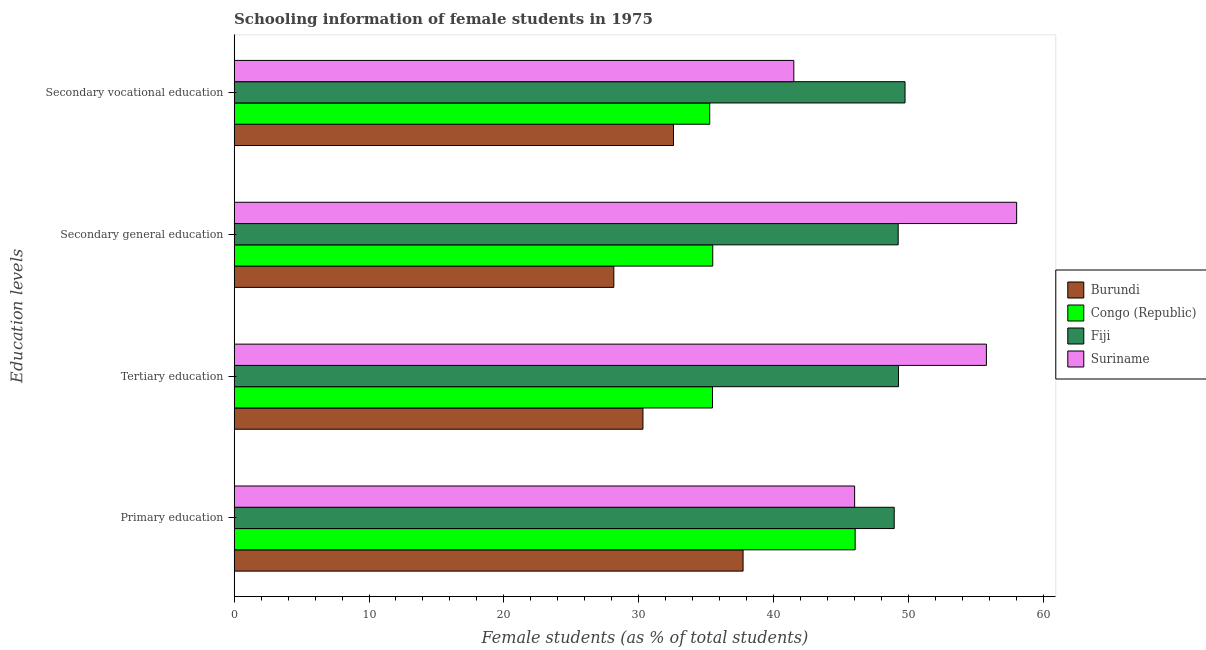How many different coloured bars are there?
Your response must be concise. 4. How many bars are there on the 2nd tick from the top?
Offer a terse response. 4. How many bars are there on the 4th tick from the bottom?
Your response must be concise. 4. What is the label of the 1st group of bars from the top?
Your response must be concise. Secondary vocational education. What is the percentage of female students in primary education in Burundi?
Make the answer very short. 37.73. Across all countries, what is the maximum percentage of female students in primary education?
Offer a very short reply. 48.94. Across all countries, what is the minimum percentage of female students in secondary vocational education?
Your answer should be very brief. 32.57. In which country was the percentage of female students in primary education maximum?
Provide a succinct answer. Fiji. In which country was the percentage of female students in tertiary education minimum?
Ensure brevity in your answer.  Burundi. What is the total percentage of female students in secondary education in the graph?
Provide a succinct answer. 170.87. What is the difference between the percentage of female students in secondary vocational education in Burundi and that in Fiji?
Your response must be concise. -17.16. What is the difference between the percentage of female students in tertiary education in Fiji and the percentage of female students in primary education in Congo (Republic)?
Give a very brief answer. 3.21. What is the average percentage of female students in primary education per country?
Your answer should be very brief. 44.68. What is the difference between the percentage of female students in secondary education and percentage of female students in primary education in Burundi?
Your response must be concise. -9.58. What is the ratio of the percentage of female students in secondary education in Burundi to that in Congo (Republic)?
Ensure brevity in your answer.  0.79. What is the difference between the highest and the second highest percentage of female students in tertiary education?
Your answer should be very brief. 6.52. What is the difference between the highest and the lowest percentage of female students in primary education?
Ensure brevity in your answer.  11.2. What does the 4th bar from the top in Tertiary education represents?
Ensure brevity in your answer.  Burundi. What does the 3rd bar from the bottom in Primary education represents?
Ensure brevity in your answer.  Fiji. Are all the bars in the graph horizontal?
Provide a short and direct response. Yes. How many countries are there in the graph?
Offer a very short reply. 4. Does the graph contain any zero values?
Ensure brevity in your answer.  No. Where does the legend appear in the graph?
Offer a very short reply. Center right. What is the title of the graph?
Give a very brief answer. Schooling information of female students in 1975. What is the label or title of the X-axis?
Offer a very short reply. Female students (as % of total students). What is the label or title of the Y-axis?
Keep it short and to the point. Education levels. What is the Female students (as % of total students) in Burundi in Primary education?
Your answer should be very brief. 37.73. What is the Female students (as % of total students) of Congo (Republic) in Primary education?
Provide a short and direct response. 46.04. What is the Female students (as % of total students) of Fiji in Primary education?
Ensure brevity in your answer.  48.94. What is the Female students (as % of total students) in Suriname in Primary education?
Offer a terse response. 46. What is the Female students (as % of total students) of Burundi in Tertiary education?
Your answer should be compact. 30.31. What is the Female students (as % of total students) of Congo (Republic) in Tertiary education?
Make the answer very short. 35.47. What is the Female students (as % of total students) in Fiji in Tertiary education?
Your response must be concise. 49.25. What is the Female students (as % of total students) in Suriname in Tertiary education?
Ensure brevity in your answer.  55.77. What is the Female students (as % of total students) of Burundi in Secondary general education?
Offer a terse response. 28.15. What is the Female students (as % of total students) of Congo (Republic) in Secondary general education?
Offer a terse response. 35.48. What is the Female students (as % of total students) in Fiji in Secondary general education?
Keep it short and to the point. 49.23. What is the Female students (as % of total students) in Suriname in Secondary general education?
Provide a short and direct response. 58.01. What is the Female students (as % of total students) of Burundi in Secondary vocational education?
Provide a succinct answer. 32.57. What is the Female students (as % of total students) in Congo (Republic) in Secondary vocational education?
Give a very brief answer. 35.26. What is the Female students (as % of total students) in Fiji in Secondary vocational education?
Your answer should be very brief. 49.74. What is the Female students (as % of total students) of Suriname in Secondary vocational education?
Give a very brief answer. 41.49. Across all Education levels, what is the maximum Female students (as % of total students) of Burundi?
Provide a succinct answer. 37.73. Across all Education levels, what is the maximum Female students (as % of total students) in Congo (Republic)?
Provide a short and direct response. 46.04. Across all Education levels, what is the maximum Female students (as % of total students) in Fiji?
Offer a very short reply. 49.74. Across all Education levels, what is the maximum Female students (as % of total students) of Suriname?
Provide a short and direct response. 58.01. Across all Education levels, what is the minimum Female students (as % of total students) in Burundi?
Make the answer very short. 28.15. Across all Education levels, what is the minimum Female students (as % of total students) in Congo (Republic)?
Ensure brevity in your answer.  35.26. Across all Education levels, what is the minimum Female students (as % of total students) in Fiji?
Provide a short and direct response. 48.94. Across all Education levels, what is the minimum Female students (as % of total students) of Suriname?
Offer a very short reply. 41.49. What is the total Female students (as % of total students) in Burundi in the graph?
Provide a short and direct response. 128.76. What is the total Female students (as % of total students) of Congo (Republic) in the graph?
Keep it short and to the point. 152.24. What is the total Female students (as % of total students) of Fiji in the graph?
Keep it short and to the point. 197.15. What is the total Female students (as % of total students) of Suriname in the graph?
Make the answer very short. 201.27. What is the difference between the Female students (as % of total students) of Burundi in Primary education and that in Tertiary education?
Make the answer very short. 7.42. What is the difference between the Female students (as % of total students) of Congo (Republic) in Primary education and that in Tertiary education?
Make the answer very short. 10.57. What is the difference between the Female students (as % of total students) in Fiji in Primary education and that in Tertiary education?
Offer a very short reply. -0.31. What is the difference between the Female students (as % of total students) in Suriname in Primary education and that in Tertiary education?
Make the answer very short. -9.77. What is the difference between the Female students (as % of total students) in Burundi in Primary education and that in Secondary general education?
Provide a short and direct response. 9.58. What is the difference between the Female students (as % of total students) in Congo (Republic) in Primary education and that in Secondary general education?
Provide a short and direct response. 10.56. What is the difference between the Female students (as % of total students) of Fiji in Primary education and that in Secondary general education?
Your answer should be compact. -0.29. What is the difference between the Female students (as % of total students) of Suriname in Primary education and that in Secondary general education?
Ensure brevity in your answer.  -12.01. What is the difference between the Female students (as % of total students) in Burundi in Primary education and that in Secondary vocational education?
Offer a terse response. 5.16. What is the difference between the Female students (as % of total students) of Congo (Republic) in Primary education and that in Secondary vocational education?
Offer a very short reply. 10.78. What is the difference between the Female students (as % of total students) in Fiji in Primary education and that in Secondary vocational education?
Make the answer very short. -0.8. What is the difference between the Female students (as % of total students) of Suriname in Primary education and that in Secondary vocational education?
Your answer should be compact. 4.51. What is the difference between the Female students (as % of total students) of Burundi in Tertiary education and that in Secondary general education?
Your response must be concise. 2.16. What is the difference between the Female students (as % of total students) in Congo (Republic) in Tertiary education and that in Secondary general education?
Provide a short and direct response. -0.02. What is the difference between the Female students (as % of total students) in Fiji in Tertiary education and that in Secondary general education?
Give a very brief answer. 0.02. What is the difference between the Female students (as % of total students) of Suriname in Tertiary education and that in Secondary general education?
Give a very brief answer. -2.24. What is the difference between the Female students (as % of total students) of Burundi in Tertiary education and that in Secondary vocational education?
Make the answer very short. -2.26. What is the difference between the Female students (as % of total students) in Congo (Republic) in Tertiary education and that in Secondary vocational education?
Make the answer very short. 0.21. What is the difference between the Female students (as % of total students) in Fiji in Tertiary education and that in Secondary vocational education?
Provide a succinct answer. -0.49. What is the difference between the Female students (as % of total students) of Suriname in Tertiary education and that in Secondary vocational education?
Provide a succinct answer. 14.28. What is the difference between the Female students (as % of total students) of Burundi in Secondary general education and that in Secondary vocational education?
Your answer should be very brief. -4.42. What is the difference between the Female students (as % of total students) in Congo (Republic) in Secondary general education and that in Secondary vocational education?
Ensure brevity in your answer.  0.22. What is the difference between the Female students (as % of total students) in Fiji in Secondary general education and that in Secondary vocational education?
Make the answer very short. -0.51. What is the difference between the Female students (as % of total students) of Suriname in Secondary general education and that in Secondary vocational education?
Your response must be concise. 16.52. What is the difference between the Female students (as % of total students) of Burundi in Primary education and the Female students (as % of total students) of Congo (Republic) in Tertiary education?
Make the answer very short. 2.27. What is the difference between the Female students (as % of total students) in Burundi in Primary education and the Female students (as % of total students) in Fiji in Tertiary education?
Your response must be concise. -11.52. What is the difference between the Female students (as % of total students) in Burundi in Primary education and the Female students (as % of total students) in Suriname in Tertiary education?
Provide a succinct answer. -18.04. What is the difference between the Female students (as % of total students) of Congo (Republic) in Primary education and the Female students (as % of total students) of Fiji in Tertiary education?
Offer a very short reply. -3.21. What is the difference between the Female students (as % of total students) in Congo (Republic) in Primary education and the Female students (as % of total students) in Suriname in Tertiary education?
Make the answer very short. -9.73. What is the difference between the Female students (as % of total students) in Fiji in Primary education and the Female students (as % of total students) in Suriname in Tertiary education?
Give a very brief answer. -6.83. What is the difference between the Female students (as % of total students) of Burundi in Primary education and the Female students (as % of total students) of Congo (Republic) in Secondary general education?
Your response must be concise. 2.25. What is the difference between the Female students (as % of total students) of Burundi in Primary education and the Female students (as % of total students) of Fiji in Secondary general education?
Your answer should be very brief. -11.5. What is the difference between the Female students (as % of total students) of Burundi in Primary education and the Female students (as % of total students) of Suriname in Secondary general education?
Give a very brief answer. -20.28. What is the difference between the Female students (as % of total students) of Congo (Republic) in Primary education and the Female students (as % of total students) of Fiji in Secondary general education?
Your response must be concise. -3.19. What is the difference between the Female students (as % of total students) of Congo (Republic) in Primary education and the Female students (as % of total students) of Suriname in Secondary general education?
Provide a short and direct response. -11.97. What is the difference between the Female students (as % of total students) in Fiji in Primary education and the Female students (as % of total students) in Suriname in Secondary general education?
Your answer should be very brief. -9.08. What is the difference between the Female students (as % of total students) in Burundi in Primary education and the Female students (as % of total students) in Congo (Republic) in Secondary vocational education?
Keep it short and to the point. 2.47. What is the difference between the Female students (as % of total students) of Burundi in Primary education and the Female students (as % of total students) of Fiji in Secondary vocational education?
Ensure brevity in your answer.  -12.01. What is the difference between the Female students (as % of total students) of Burundi in Primary education and the Female students (as % of total students) of Suriname in Secondary vocational education?
Your response must be concise. -3.76. What is the difference between the Female students (as % of total students) in Congo (Republic) in Primary education and the Female students (as % of total students) in Fiji in Secondary vocational education?
Your response must be concise. -3.7. What is the difference between the Female students (as % of total students) in Congo (Republic) in Primary education and the Female students (as % of total students) in Suriname in Secondary vocational education?
Give a very brief answer. 4.55. What is the difference between the Female students (as % of total students) in Fiji in Primary education and the Female students (as % of total students) in Suriname in Secondary vocational education?
Offer a terse response. 7.44. What is the difference between the Female students (as % of total students) in Burundi in Tertiary education and the Female students (as % of total students) in Congo (Republic) in Secondary general education?
Ensure brevity in your answer.  -5.17. What is the difference between the Female students (as % of total students) of Burundi in Tertiary education and the Female students (as % of total students) of Fiji in Secondary general education?
Your response must be concise. -18.92. What is the difference between the Female students (as % of total students) in Burundi in Tertiary education and the Female students (as % of total students) in Suriname in Secondary general education?
Give a very brief answer. -27.7. What is the difference between the Female students (as % of total students) of Congo (Republic) in Tertiary education and the Female students (as % of total students) of Fiji in Secondary general education?
Offer a very short reply. -13.76. What is the difference between the Female students (as % of total students) in Congo (Republic) in Tertiary education and the Female students (as % of total students) in Suriname in Secondary general education?
Your answer should be compact. -22.55. What is the difference between the Female students (as % of total students) of Fiji in Tertiary education and the Female students (as % of total students) of Suriname in Secondary general education?
Offer a very short reply. -8.76. What is the difference between the Female students (as % of total students) in Burundi in Tertiary education and the Female students (as % of total students) in Congo (Republic) in Secondary vocational education?
Provide a short and direct response. -4.95. What is the difference between the Female students (as % of total students) in Burundi in Tertiary education and the Female students (as % of total students) in Fiji in Secondary vocational education?
Offer a terse response. -19.43. What is the difference between the Female students (as % of total students) of Burundi in Tertiary education and the Female students (as % of total students) of Suriname in Secondary vocational education?
Make the answer very short. -11.18. What is the difference between the Female students (as % of total students) in Congo (Republic) in Tertiary education and the Female students (as % of total students) in Fiji in Secondary vocational education?
Give a very brief answer. -14.27. What is the difference between the Female students (as % of total students) of Congo (Republic) in Tertiary education and the Female students (as % of total students) of Suriname in Secondary vocational education?
Provide a short and direct response. -6.03. What is the difference between the Female students (as % of total students) of Fiji in Tertiary education and the Female students (as % of total students) of Suriname in Secondary vocational education?
Offer a very short reply. 7.76. What is the difference between the Female students (as % of total students) in Burundi in Secondary general education and the Female students (as % of total students) in Congo (Republic) in Secondary vocational education?
Provide a succinct answer. -7.11. What is the difference between the Female students (as % of total students) of Burundi in Secondary general education and the Female students (as % of total students) of Fiji in Secondary vocational education?
Ensure brevity in your answer.  -21.59. What is the difference between the Female students (as % of total students) in Burundi in Secondary general education and the Female students (as % of total students) in Suriname in Secondary vocational education?
Provide a short and direct response. -13.34. What is the difference between the Female students (as % of total students) in Congo (Republic) in Secondary general education and the Female students (as % of total students) in Fiji in Secondary vocational education?
Make the answer very short. -14.26. What is the difference between the Female students (as % of total students) of Congo (Republic) in Secondary general education and the Female students (as % of total students) of Suriname in Secondary vocational education?
Make the answer very short. -6.01. What is the difference between the Female students (as % of total students) in Fiji in Secondary general education and the Female students (as % of total students) in Suriname in Secondary vocational education?
Give a very brief answer. 7.74. What is the average Female students (as % of total students) in Burundi per Education levels?
Your response must be concise. 32.19. What is the average Female students (as % of total students) of Congo (Republic) per Education levels?
Your response must be concise. 38.06. What is the average Female students (as % of total students) in Fiji per Education levels?
Ensure brevity in your answer.  49.29. What is the average Female students (as % of total students) in Suriname per Education levels?
Your answer should be compact. 50.32. What is the difference between the Female students (as % of total students) of Burundi and Female students (as % of total students) of Congo (Republic) in Primary education?
Provide a succinct answer. -8.31. What is the difference between the Female students (as % of total students) of Burundi and Female students (as % of total students) of Fiji in Primary education?
Your response must be concise. -11.2. What is the difference between the Female students (as % of total students) of Burundi and Female students (as % of total students) of Suriname in Primary education?
Offer a terse response. -8.27. What is the difference between the Female students (as % of total students) of Congo (Republic) and Female students (as % of total students) of Fiji in Primary education?
Make the answer very short. -2.9. What is the difference between the Female students (as % of total students) of Congo (Republic) and Female students (as % of total students) of Suriname in Primary education?
Your response must be concise. 0.04. What is the difference between the Female students (as % of total students) in Fiji and Female students (as % of total students) in Suriname in Primary education?
Your response must be concise. 2.94. What is the difference between the Female students (as % of total students) of Burundi and Female students (as % of total students) of Congo (Republic) in Tertiary education?
Offer a terse response. -5.16. What is the difference between the Female students (as % of total students) in Burundi and Female students (as % of total students) in Fiji in Tertiary education?
Give a very brief answer. -18.94. What is the difference between the Female students (as % of total students) in Burundi and Female students (as % of total students) in Suriname in Tertiary education?
Offer a very short reply. -25.46. What is the difference between the Female students (as % of total students) in Congo (Republic) and Female students (as % of total students) in Fiji in Tertiary education?
Your answer should be very brief. -13.79. What is the difference between the Female students (as % of total students) in Congo (Republic) and Female students (as % of total students) in Suriname in Tertiary education?
Provide a succinct answer. -20.3. What is the difference between the Female students (as % of total students) in Fiji and Female students (as % of total students) in Suriname in Tertiary education?
Your response must be concise. -6.52. What is the difference between the Female students (as % of total students) in Burundi and Female students (as % of total students) in Congo (Republic) in Secondary general education?
Give a very brief answer. -7.33. What is the difference between the Female students (as % of total students) of Burundi and Female students (as % of total students) of Fiji in Secondary general education?
Provide a succinct answer. -21.08. What is the difference between the Female students (as % of total students) in Burundi and Female students (as % of total students) in Suriname in Secondary general education?
Offer a terse response. -29.86. What is the difference between the Female students (as % of total students) of Congo (Republic) and Female students (as % of total students) of Fiji in Secondary general education?
Ensure brevity in your answer.  -13.75. What is the difference between the Female students (as % of total students) of Congo (Republic) and Female students (as % of total students) of Suriname in Secondary general education?
Keep it short and to the point. -22.53. What is the difference between the Female students (as % of total students) in Fiji and Female students (as % of total students) in Suriname in Secondary general education?
Offer a terse response. -8.78. What is the difference between the Female students (as % of total students) of Burundi and Female students (as % of total students) of Congo (Republic) in Secondary vocational education?
Your answer should be compact. -2.69. What is the difference between the Female students (as % of total students) of Burundi and Female students (as % of total students) of Fiji in Secondary vocational education?
Provide a short and direct response. -17.16. What is the difference between the Female students (as % of total students) in Burundi and Female students (as % of total students) in Suriname in Secondary vocational education?
Ensure brevity in your answer.  -8.92. What is the difference between the Female students (as % of total students) of Congo (Republic) and Female students (as % of total students) of Fiji in Secondary vocational education?
Your answer should be compact. -14.48. What is the difference between the Female students (as % of total students) in Congo (Republic) and Female students (as % of total students) in Suriname in Secondary vocational education?
Your answer should be compact. -6.23. What is the difference between the Female students (as % of total students) in Fiji and Female students (as % of total students) in Suriname in Secondary vocational education?
Give a very brief answer. 8.25. What is the ratio of the Female students (as % of total students) of Burundi in Primary education to that in Tertiary education?
Your answer should be very brief. 1.24. What is the ratio of the Female students (as % of total students) in Congo (Republic) in Primary education to that in Tertiary education?
Give a very brief answer. 1.3. What is the ratio of the Female students (as % of total students) of Suriname in Primary education to that in Tertiary education?
Give a very brief answer. 0.82. What is the ratio of the Female students (as % of total students) in Burundi in Primary education to that in Secondary general education?
Provide a short and direct response. 1.34. What is the ratio of the Female students (as % of total students) in Congo (Republic) in Primary education to that in Secondary general education?
Offer a terse response. 1.3. What is the ratio of the Female students (as % of total students) in Suriname in Primary education to that in Secondary general education?
Offer a terse response. 0.79. What is the ratio of the Female students (as % of total students) of Burundi in Primary education to that in Secondary vocational education?
Give a very brief answer. 1.16. What is the ratio of the Female students (as % of total students) of Congo (Republic) in Primary education to that in Secondary vocational education?
Give a very brief answer. 1.31. What is the ratio of the Female students (as % of total students) of Fiji in Primary education to that in Secondary vocational education?
Provide a succinct answer. 0.98. What is the ratio of the Female students (as % of total students) of Suriname in Primary education to that in Secondary vocational education?
Make the answer very short. 1.11. What is the ratio of the Female students (as % of total students) in Burundi in Tertiary education to that in Secondary general education?
Provide a succinct answer. 1.08. What is the ratio of the Female students (as % of total students) in Fiji in Tertiary education to that in Secondary general education?
Provide a succinct answer. 1. What is the ratio of the Female students (as % of total students) of Suriname in Tertiary education to that in Secondary general education?
Offer a terse response. 0.96. What is the ratio of the Female students (as % of total students) of Burundi in Tertiary education to that in Secondary vocational education?
Provide a short and direct response. 0.93. What is the ratio of the Female students (as % of total students) in Congo (Republic) in Tertiary education to that in Secondary vocational education?
Offer a terse response. 1.01. What is the ratio of the Female students (as % of total students) in Fiji in Tertiary education to that in Secondary vocational education?
Offer a terse response. 0.99. What is the ratio of the Female students (as % of total students) of Suriname in Tertiary education to that in Secondary vocational education?
Offer a very short reply. 1.34. What is the ratio of the Female students (as % of total students) in Burundi in Secondary general education to that in Secondary vocational education?
Provide a succinct answer. 0.86. What is the ratio of the Female students (as % of total students) in Congo (Republic) in Secondary general education to that in Secondary vocational education?
Give a very brief answer. 1.01. What is the ratio of the Female students (as % of total students) in Suriname in Secondary general education to that in Secondary vocational education?
Give a very brief answer. 1.4. What is the difference between the highest and the second highest Female students (as % of total students) of Burundi?
Your answer should be compact. 5.16. What is the difference between the highest and the second highest Female students (as % of total students) of Congo (Republic)?
Provide a succinct answer. 10.56. What is the difference between the highest and the second highest Female students (as % of total students) of Fiji?
Make the answer very short. 0.49. What is the difference between the highest and the second highest Female students (as % of total students) of Suriname?
Your response must be concise. 2.24. What is the difference between the highest and the lowest Female students (as % of total students) in Burundi?
Your response must be concise. 9.58. What is the difference between the highest and the lowest Female students (as % of total students) of Congo (Republic)?
Your response must be concise. 10.78. What is the difference between the highest and the lowest Female students (as % of total students) of Fiji?
Offer a terse response. 0.8. What is the difference between the highest and the lowest Female students (as % of total students) of Suriname?
Provide a short and direct response. 16.52. 